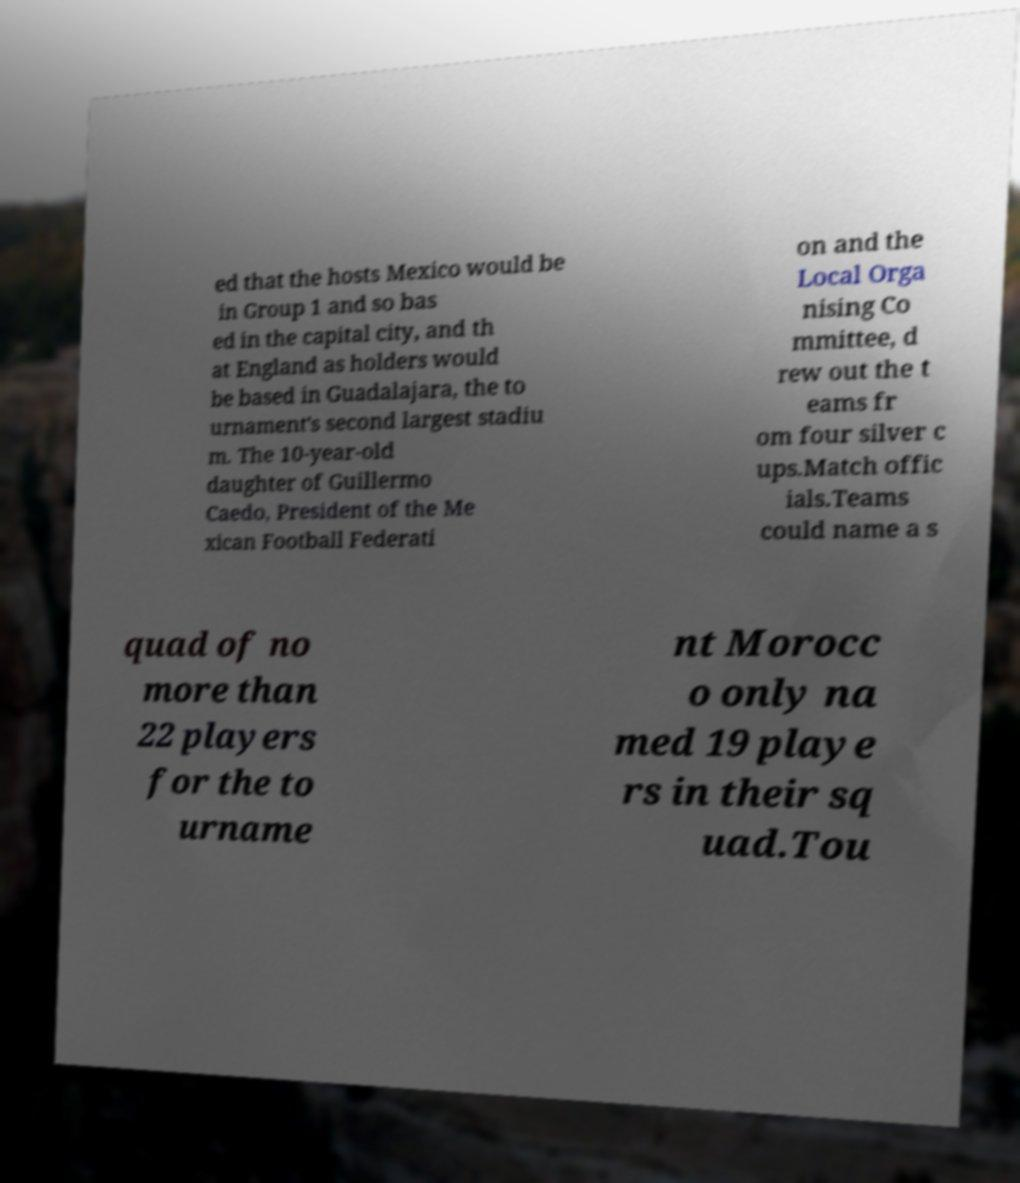Could you extract and type out the text from this image? ed that the hosts Mexico would be in Group 1 and so bas ed in the capital city, and th at England as holders would be based in Guadalajara, the to urnament's second largest stadiu m. The 10-year-old daughter of Guillermo Caedo, President of the Me xican Football Federati on and the Local Orga nising Co mmittee, d rew out the t eams fr om four silver c ups.Match offic ials.Teams could name a s quad of no more than 22 players for the to urname nt Morocc o only na med 19 playe rs in their sq uad.Tou 